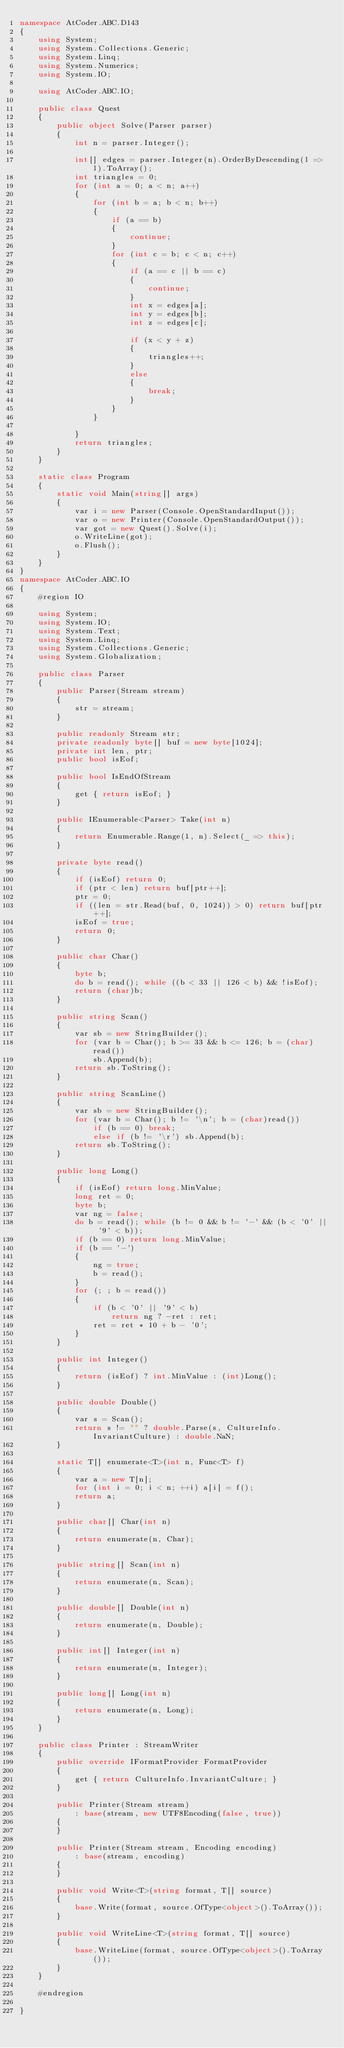<code> <loc_0><loc_0><loc_500><loc_500><_C#_>namespace AtCoder.ABC.D143
{
    using System;
    using System.Collections.Generic;
    using System.Linq;
    using System.Numerics;
    using System.IO;

    using AtCoder.ABC.IO;

    public class Quest
    {
        public object Solve(Parser parser)
        {
            int n = parser.Integer();

            int[] edges = parser.Integer(n).OrderByDescending(l => l).ToArray();
            int triangles = 0;
            for (int a = 0; a < n; a++)
            {
                for (int b = a; b < n; b++)
                {
                    if (a == b)
                    {
                        continue;
                    }
                    for (int c = b; c < n; c++)
                    {
                        if (a == c || b == c)
                        {
                            continue;
                        }
                        int x = edges[a];
                        int y = edges[b];
                        int z = edges[c];

                        if (x < y + z)
                        {
                            triangles++;
                        }
                        else
                        {
                            break;
                        }
                    }
                }

            }
            return triangles;
        }
    }

    static class Program
    {
        static void Main(string[] args)
        {
            var i = new Parser(Console.OpenStandardInput());
            var o = new Printer(Console.OpenStandardOutput());
            var got = new Quest().Solve(i);
            o.WriteLine(got);
            o.Flush();
        }
    }
}
namespace AtCoder.ABC.IO
{
    #region IO

    using System;
    using System.IO;
    using System.Text;
    using System.Linq;
    using System.Collections.Generic;
    using System.Globalization;

    public class Parser
    {
        public Parser(Stream stream)
        {
            str = stream;
        }

        public readonly Stream str;
        private readonly byte[] buf = new byte[1024];
        private int len, ptr;
        public bool isEof;

        public bool IsEndOfStream
        {
            get { return isEof; }
        }

        public IEnumerable<Parser> Take(int n)
        {
            return Enumerable.Range(1, n).Select(_ => this);
        }

        private byte read()
        {
            if (isEof) return 0;
            if (ptr < len) return buf[ptr++];
            ptr = 0;
            if ((len = str.Read(buf, 0, 1024)) > 0) return buf[ptr++];
            isEof = true;
            return 0;
        }

        public char Char()
        {
            byte b;
            do b = read(); while ((b < 33 || 126 < b) && !isEof);
            return (char)b;
        }

        public string Scan()
        {
            var sb = new StringBuilder();
            for (var b = Char(); b >= 33 && b <= 126; b = (char)read())
                sb.Append(b);
            return sb.ToString();
        }

        public string ScanLine()
        {
            var sb = new StringBuilder();
            for (var b = Char(); b != '\n'; b = (char)read())
                if (b == 0) break;
                else if (b != '\r') sb.Append(b);
            return sb.ToString();
        }

        public long Long()
        {
            if (isEof) return long.MinValue;
            long ret = 0;
            byte b;
            var ng = false;
            do b = read(); while (b != 0 && b != '-' && (b < '0' || '9' < b));
            if (b == 0) return long.MinValue;
            if (b == '-')
            {
                ng = true;
                b = read();
            }
            for (; ; b = read())
            {
                if (b < '0' || '9' < b)
                    return ng ? -ret : ret;
                ret = ret * 10 + b - '0';
            }
        }

        public int Integer()
        {
            return (isEof) ? int.MinValue : (int)Long();
        }

        public double Double()
        {
            var s = Scan();
            return s != "" ? double.Parse(s, CultureInfo.InvariantCulture) : double.NaN;
        }

        static T[] enumerate<T>(int n, Func<T> f)
        {
            var a = new T[n];
            for (int i = 0; i < n; ++i) a[i] = f();
            return a;
        }

        public char[] Char(int n)
        {
            return enumerate(n, Char);
        }

        public string[] Scan(int n)
        {
            return enumerate(n, Scan);
        }

        public double[] Double(int n)
        {
            return enumerate(n, Double);
        }

        public int[] Integer(int n)
        {
            return enumerate(n, Integer);
        }

        public long[] Long(int n)
        {
            return enumerate(n, Long);
        }
    }

    public class Printer : StreamWriter
    {
        public override IFormatProvider FormatProvider
        {
            get { return CultureInfo.InvariantCulture; }
        }

        public Printer(Stream stream)
            : base(stream, new UTF8Encoding(false, true))
        {
        }

        public Printer(Stream stream, Encoding encoding)
            : base(stream, encoding)
        {
        }

        public void Write<T>(string format, T[] source)
        {
            base.Write(format, source.OfType<object>().ToArray());
        }

        public void WriteLine<T>(string format, T[] source)
        {
            base.WriteLine(format, source.OfType<object>().ToArray());
        }
    }

    #endregion

}</code> 